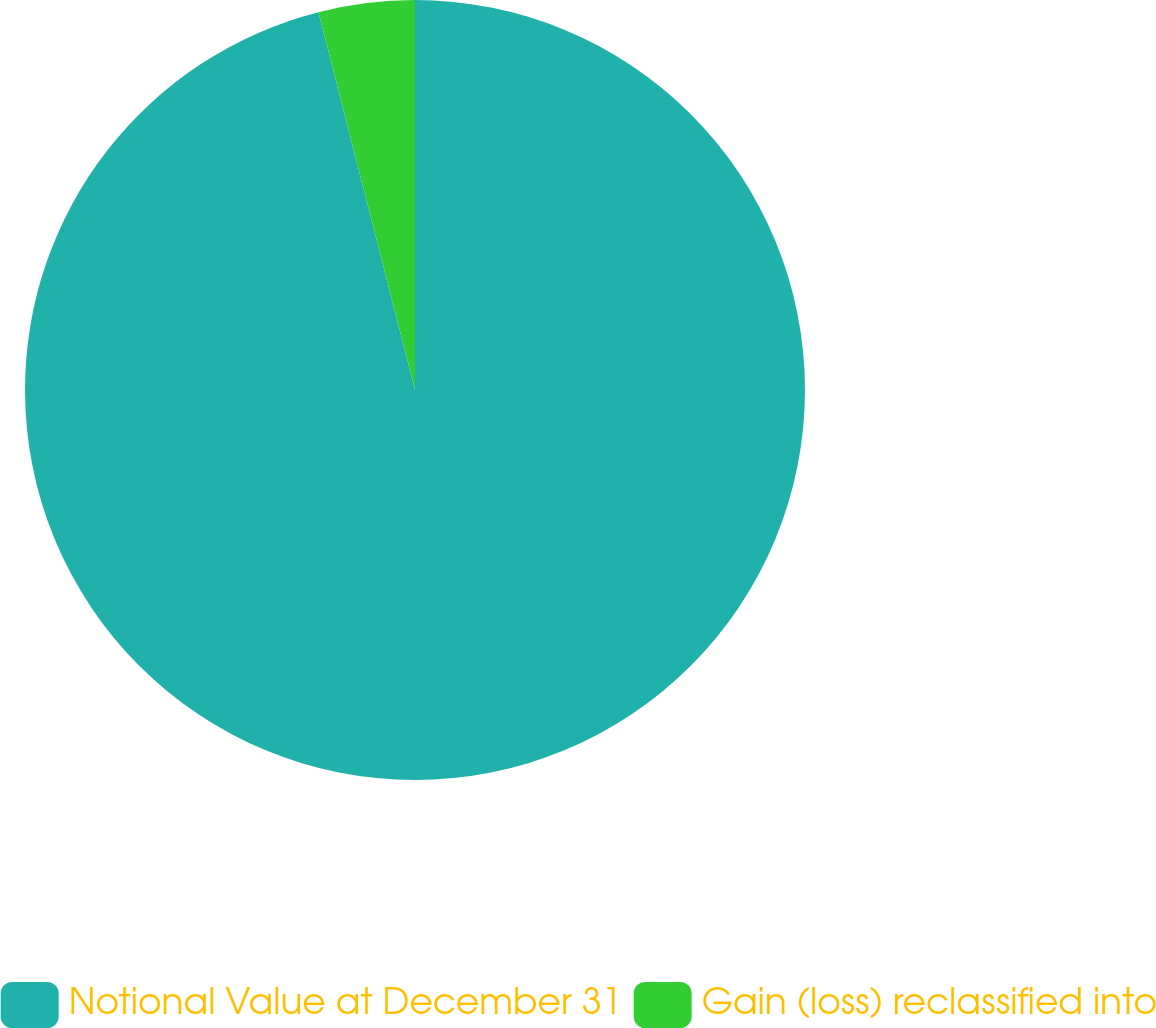Convert chart. <chart><loc_0><loc_0><loc_500><loc_500><pie_chart><fcel>Notional Value at December 31<fcel>Gain (loss) reclassified into<nl><fcel>96.02%<fcel>3.98%<nl></chart> 